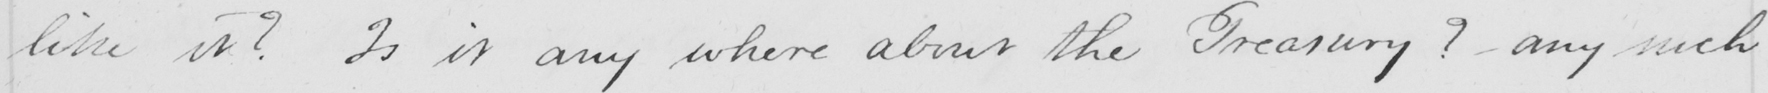Transcribe the text shown in this historical manuscript line. like it ?  Is it any where about the Treasury ?  - any such 